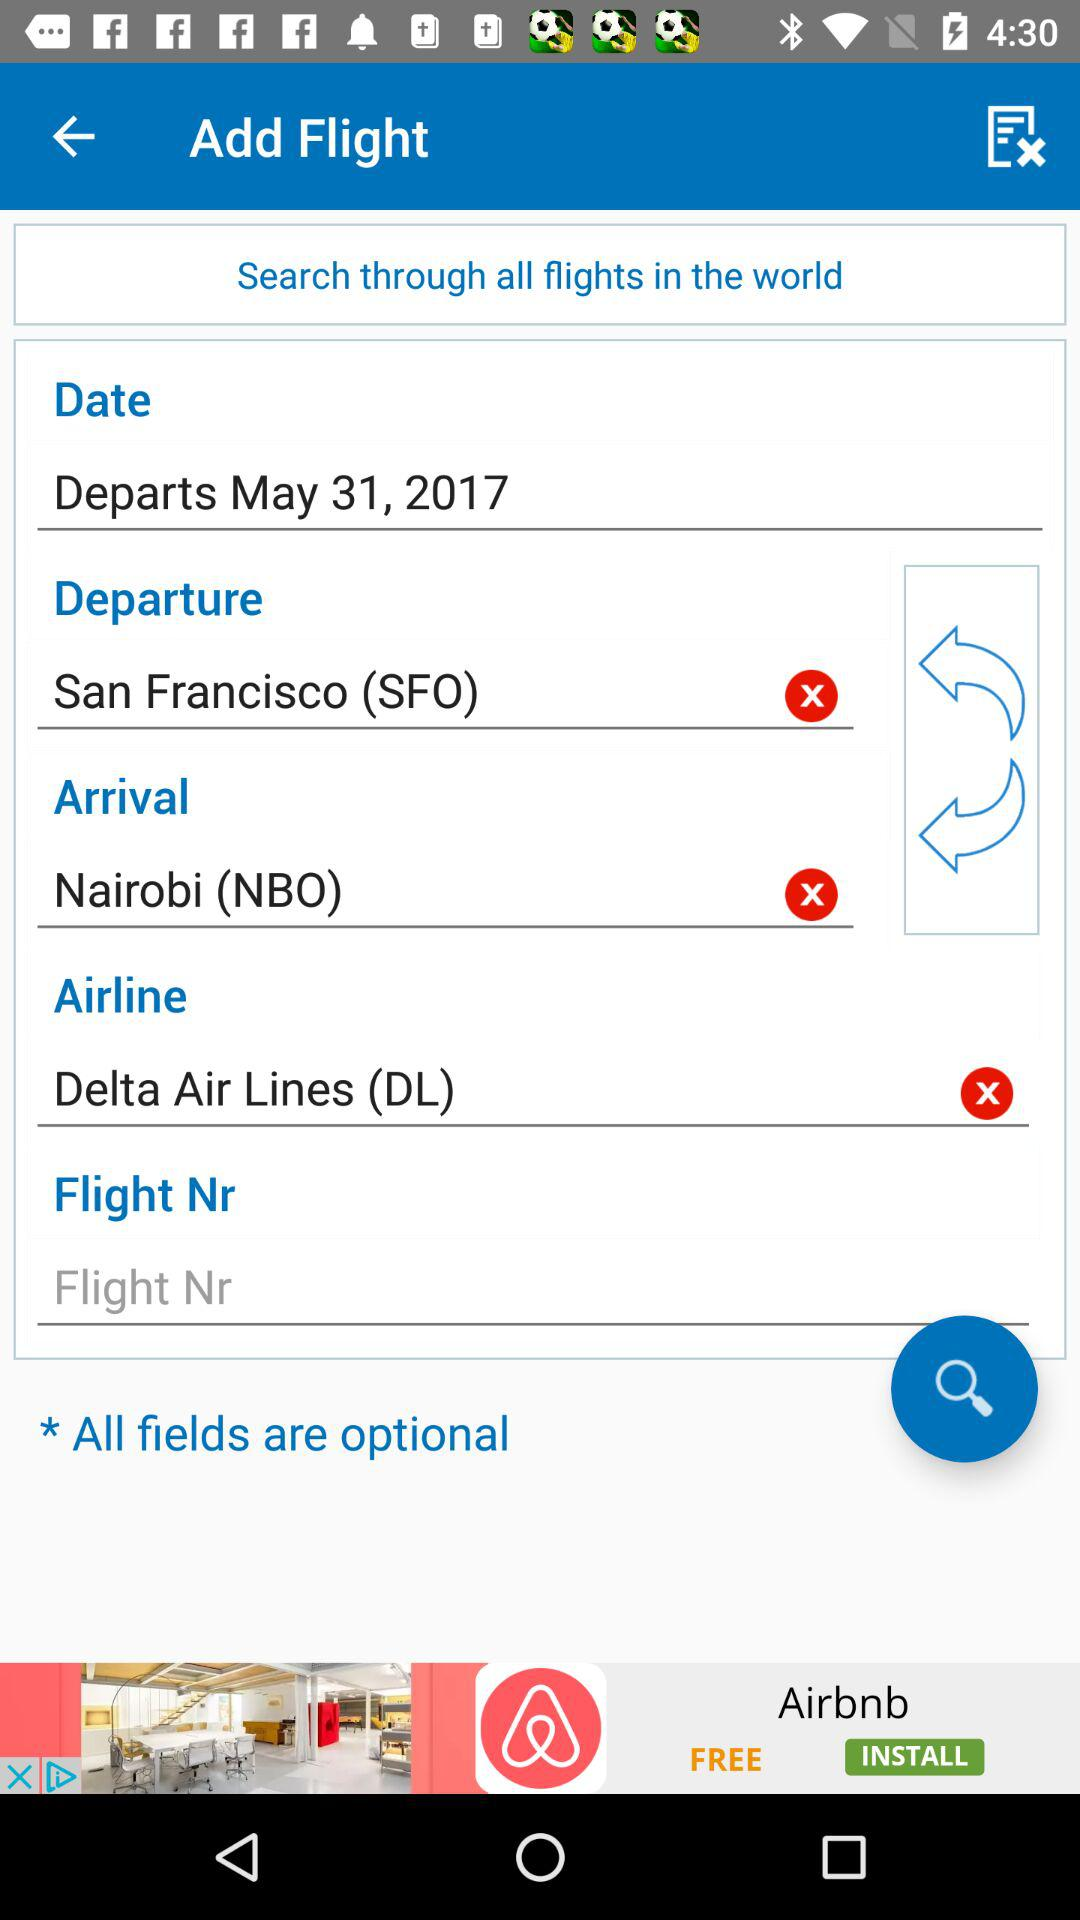What is the flight number?
When the provided information is insufficient, respond with <no answer>. <no answer> 